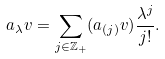Convert formula to latex. <formula><loc_0><loc_0><loc_500><loc_500>a _ { \lambda } v = \sum _ { j \in \mathbb { Z _ { + } } } ( a _ { ( j ) } v ) \frac { \lambda ^ { j } } { j ! } .</formula> 